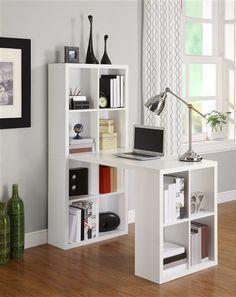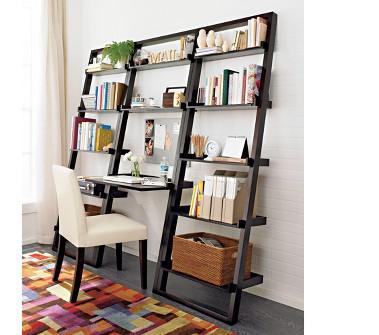The first image is the image on the left, the second image is the image on the right. Analyze the images presented: Is the assertion "A combination desk and shelf unit is built at an angle to a wall, becoming wider as it gets closer to the floor, with a small desk area in the center." valid? Answer yes or no. Yes. The first image is the image on the left, the second image is the image on the right. Analyze the images presented: Is the assertion "One image features an open-backed shelf with a front that angles toward a white wall like a ladder." valid? Answer yes or no. Yes. 